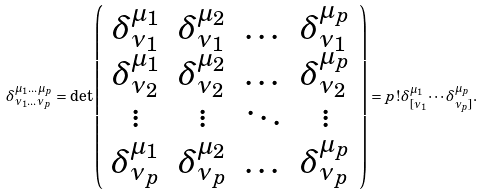Convert formula to latex. <formula><loc_0><loc_0><loc_500><loc_500>\delta ^ { \mu _ { 1 } \dots \mu _ { p } } _ { \nu _ { 1 } \dots \nu _ { p } } = \det \left ( \begin{array} { c c c c } \delta ^ { \mu _ { 1 } } _ { \nu _ { 1 } } & \delta ^ { \mu _ { 2 } } _ { \nu _ { 1 } } & \dots & \delta ^ { \mu _ { p } } _ { \nu _ { 1 } } \\ \delta ^ { \mu _ { 1 } } _ { \nu _ { 2 } } & \delta ^ { \mu _ { 2 } } _ { \nu _ { 2 } } & \dots & \delta ^ { \mu _ { p } } _ { \nu _ { 2 } } \\ \vdots & \vdots & \ddots & \vdots \\ \delta ^ { \mu _ { 1 } } _ { \nu _ { p } } & \delta ^ { \mu _ { 2 } } _ { \nu _ { p } } & \dots & \delta ^ { \mu _ { p } } _ { \nu _ { p } } \end{array} \right ) = p ! \delta ^ { \mu _ { 1 } } _ { [ \nu _ { 1 } } \cdots \delta ^ { \mu _ { p } } _ { \nu _ { p } ] } .</formula> 